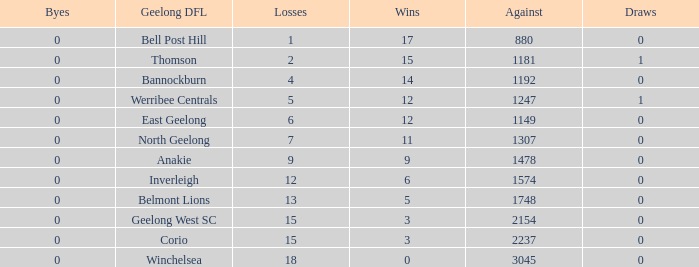What is the lowest number of wins where the byes are less than 0? None. Write the full table. {'header': ['Byes', 'Geelong DFL', 'Losses', 'Wins', 'Against', 'Draws'], 'rows': [['0', 'Bell Post Hill', '1', '17', '880', '0'], ['0', 'Thomson', '2', '15', '1181', '1'], ['0', 'Bannockburn', '4', '14', '1192', '0'], ['0', 'Werribee Centrals', '5', '12', '1247', '1'], ['0', 'East Geelong', '6', '12', '1149', '0'], ['0', 'North Geelong', '7', '11', '1307', '0'], ['0', 'Anakie', '9', '9', '1478', '0'], ['0', 'Inverleigh', '12', '6', '1574', '0'], ['0', 'Belmont Lions', '13', '5', '1748', '0'], ['0', 'Geelong West SC', '15', '3', '2154', '0'], ['0', 'Corio', '15', '3', '2237', '0'], ['0', 'Winchelsea', '18', '0', '3045', '0']]} 